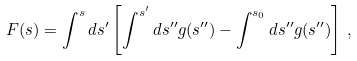Convert formula to latex. <formula><loc_0><loc_0><loc_500><loc_500>F ( s ) = \int ^ { s } d s ^ { \prime } \left [ \int ^ { s ^ { \prime } } d s ^ { \prime \prime } g ( s ^ { \prime \prime } ) - \int ^ { s _ { 0 } } d s ^ { \prime \prime } g ( s ^ { \prime \prime } ) \right ] \, ,</formula> 